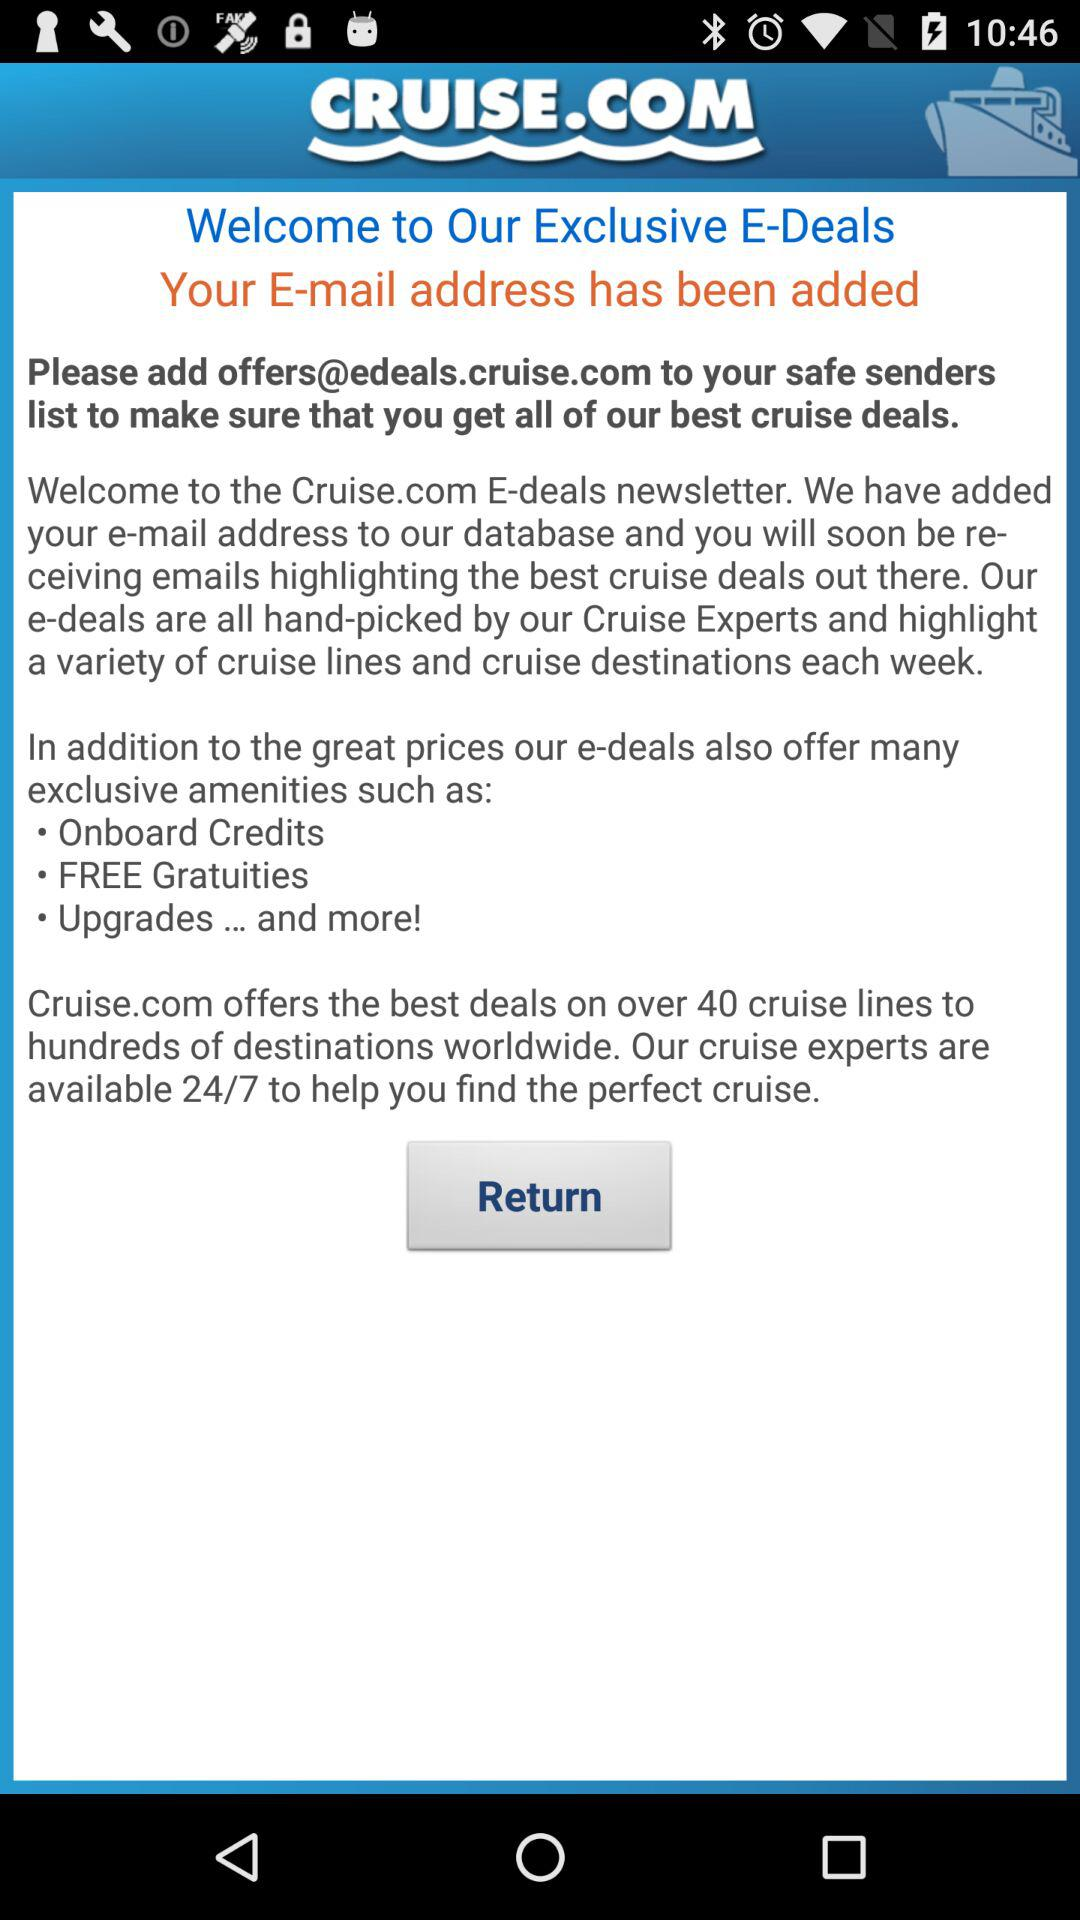For how many hours are cruise experts available to help? Cruise experts are available to help 24/7. 